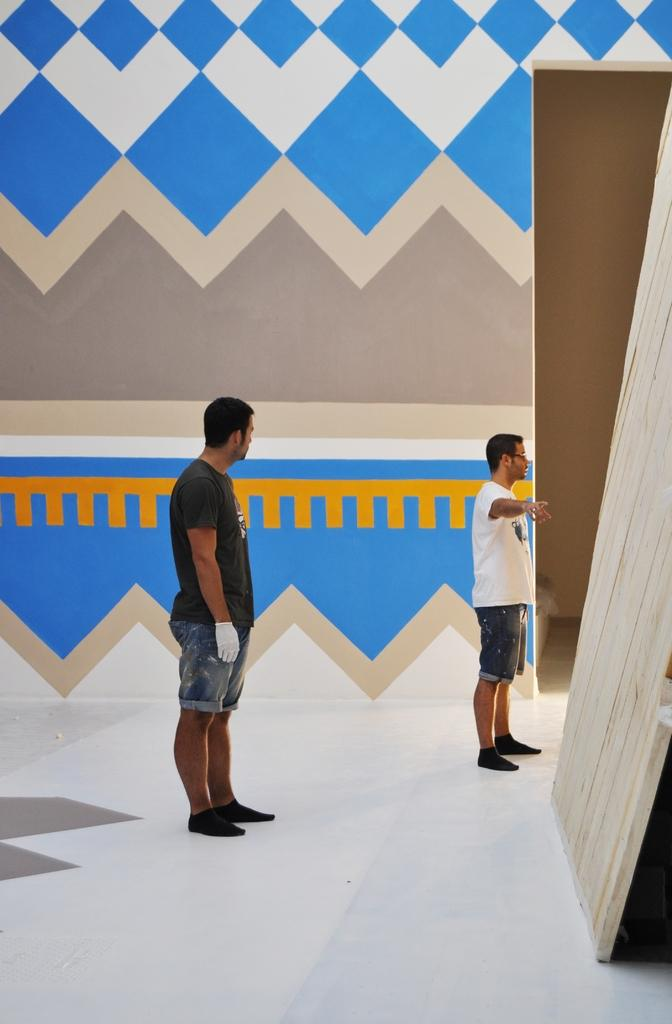How many people are in the image? There are a few people in the image. What can be seen beneath the people's feet in the image? The ground is visible in the image. What is on the wall in the image? There is a wall with a design in the image. What is located on the right side of the image? There is an object on the right side of the image. What type of chess move is being made by the person on the left side of the image? There is no chess or chessboard present in the image, so it is not possible to determine any chess moves being made. 